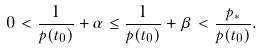<formula> <loc_0><loc_0><loc_500><loc_500>0 < \frac { 1 } { p ( t _ { 0 } ) } + \alpha \leq \frac { 1 } { p ( t _ { 0 } ) } + \beta < \frac { p _ { * } } { p ( t _ { 0 } ) } .</formula> 